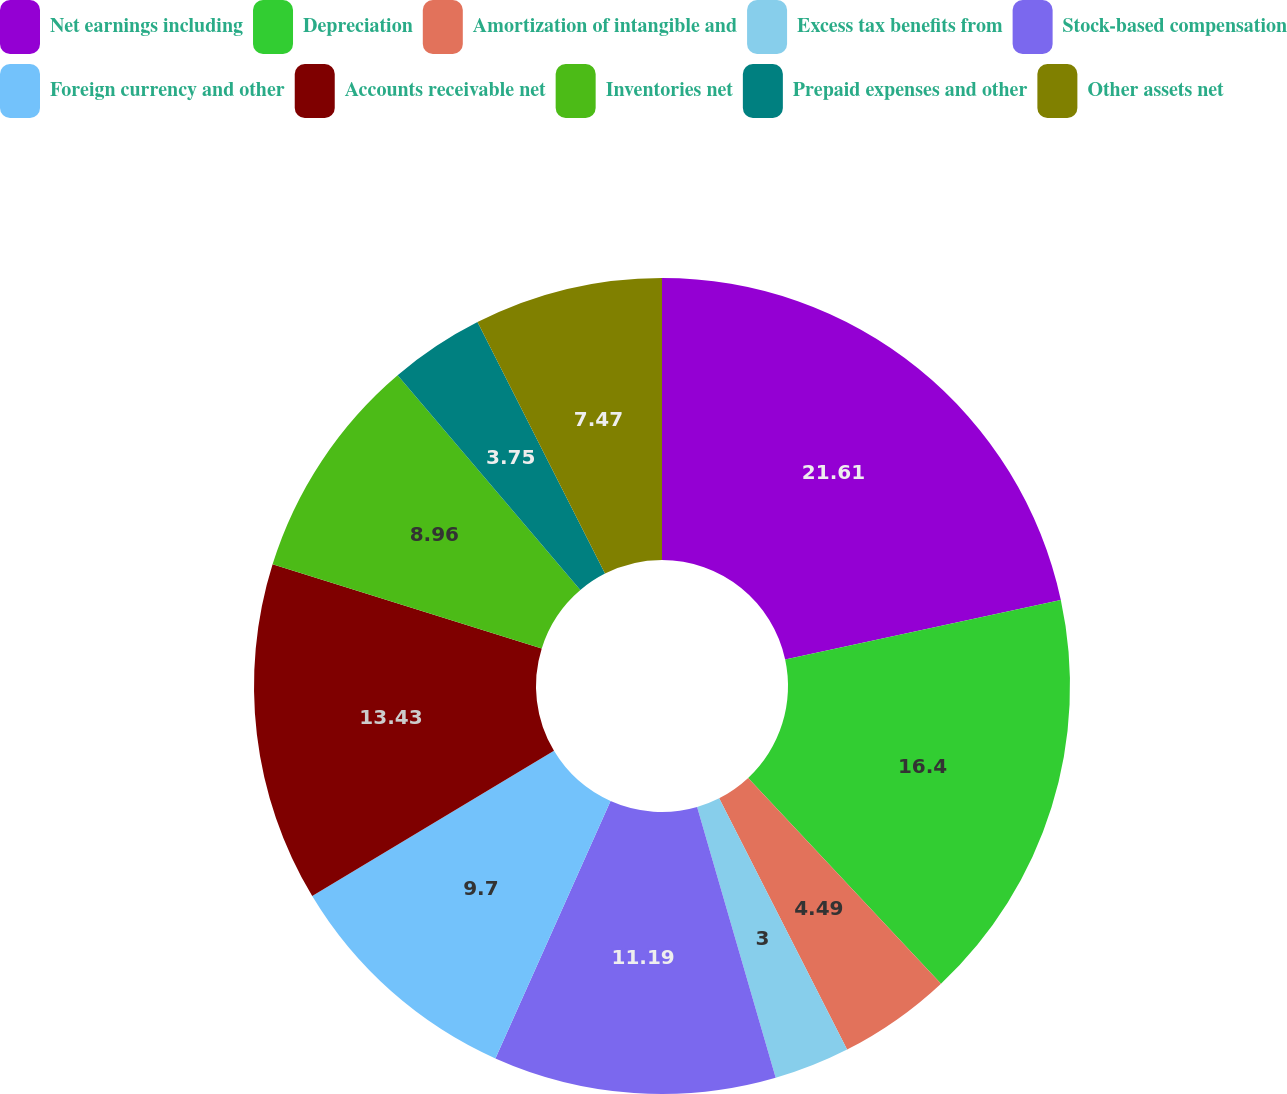Convert chart. <chart><loc_0><loc_0><loc_500><loc_500><pie_chart><fcel>Net earnings including<fcel>Depreciation<fcel>Amortization of intangible and<fcel>Excess tax benefits from<fcel>Stock-based compensation<fcel>Foreign currency and other<fcel>Accounts receivable net<fcel>Inventories net<fcel>Prepaid expenses and other<fcel>Other assets net<nl><fcel>21.62%<fcel>16.4%<fcel>4.49%<fcel>3.0%<fcel>11.19%<fcel>9.7%<fcel>13.43%<fcel>8.96%<fcel>3.75%<fcel>7.47%<nl></chart> 